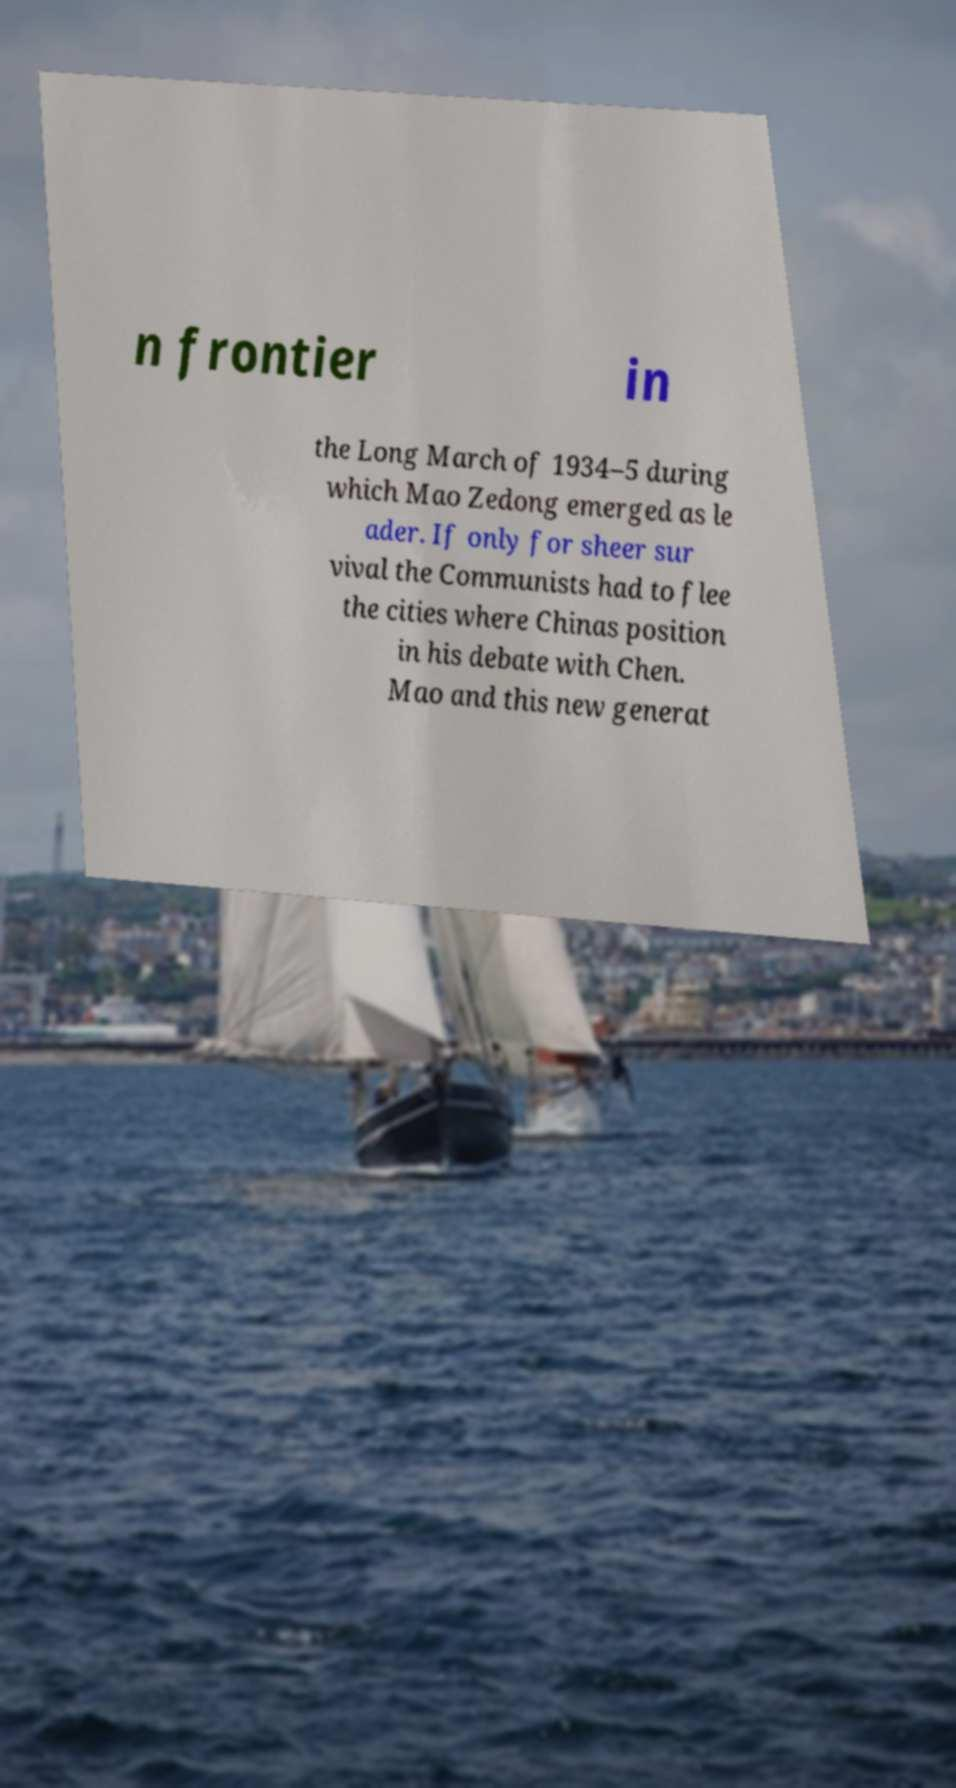Please identify and transcribe the text found in this image. n frontier in the Long March of 1934–5 during which Mao Zedong emerged as le ader. If only for sheer sur vival the Communists had to flee the cities where Chinas position in his debate with Chen. Mao and this new generat 